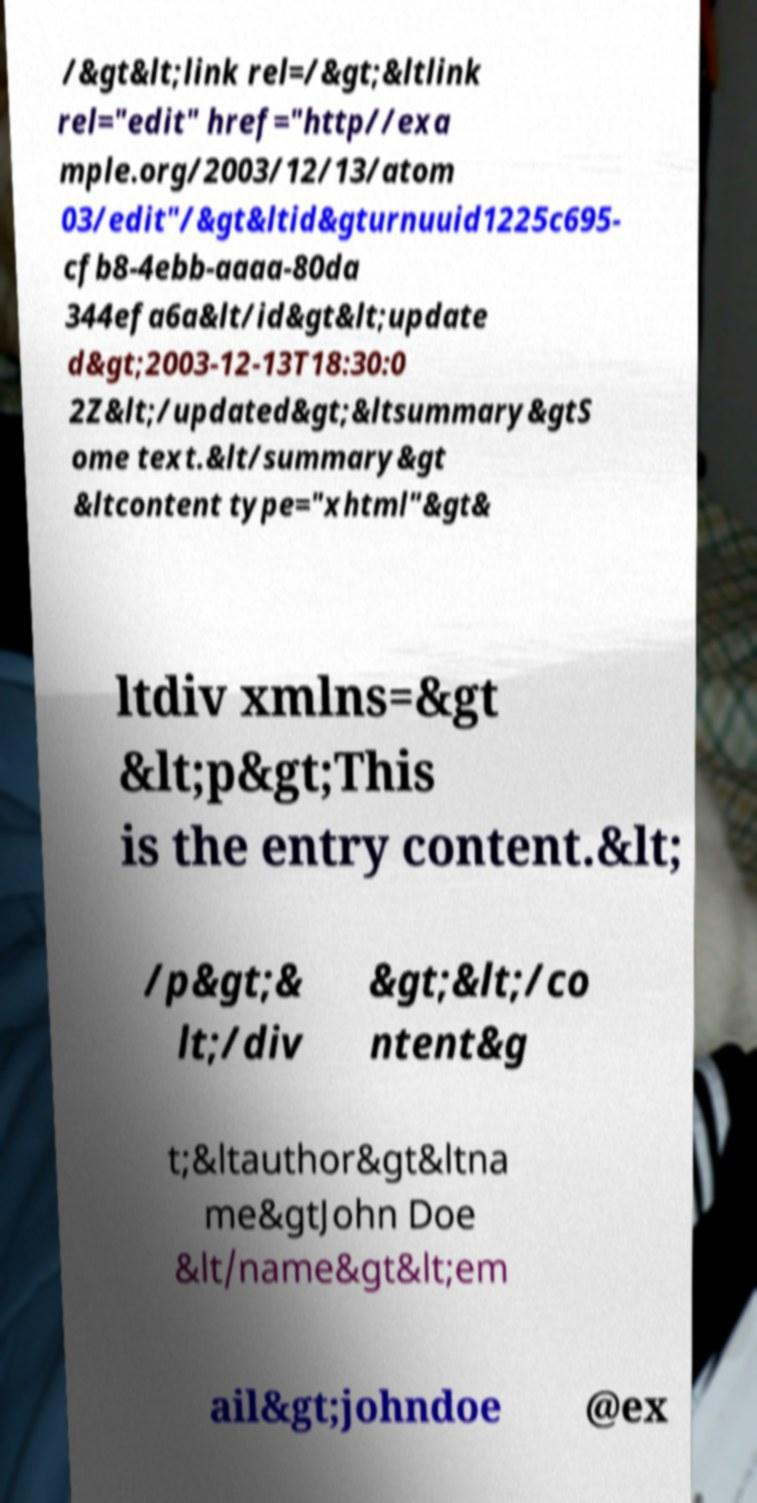Could you assist in decoding the text presented in this image and type it out clearly? /&gt&lt;link rel=/&gt;&ltlink rel="edit" href="http//exa mple.org/2003/12/13/atom 03/edit"/&gt&ltid&gturnuuid1225c695- cfb8-4ebb-aaaa-80da 344efa6a&lt/id&gt&lt;update d&gt;2003-12-13T18:30:0 2Z&lt;/updated&gt;&ltsummary&gtS ome text.&lt/summary&gt &ltcontent type="xhtml"&gt& ltdiv xmlns=&gt &lt;p&gt;This is the entry content.&lt; /p&gt;& lt;/div &gt;&lt;/co ntent&g t;&ltauthor&gt&ltna me&gtJohn Doe &lt/name&gt&lt;em ail&gt;johndoe @ex 